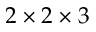<formula> <loc_0><loc_0><loc_500><loc_500>2 \times 2 \times 3</formula> 